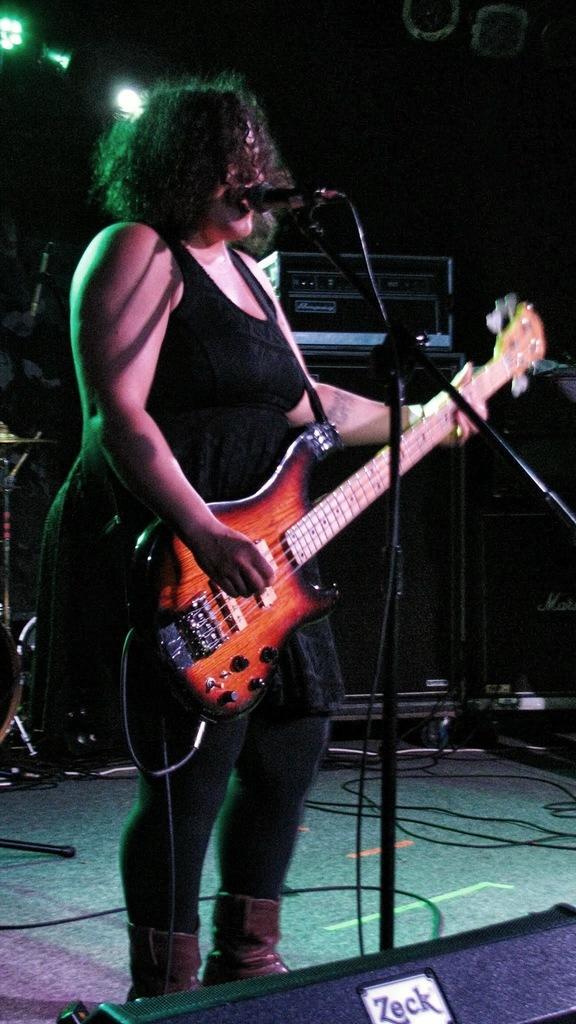How would you summarize this image in a sentence or two? This is the picture of a lady in black dress holding a guitar and standing in front of a mike and her hair is short. 